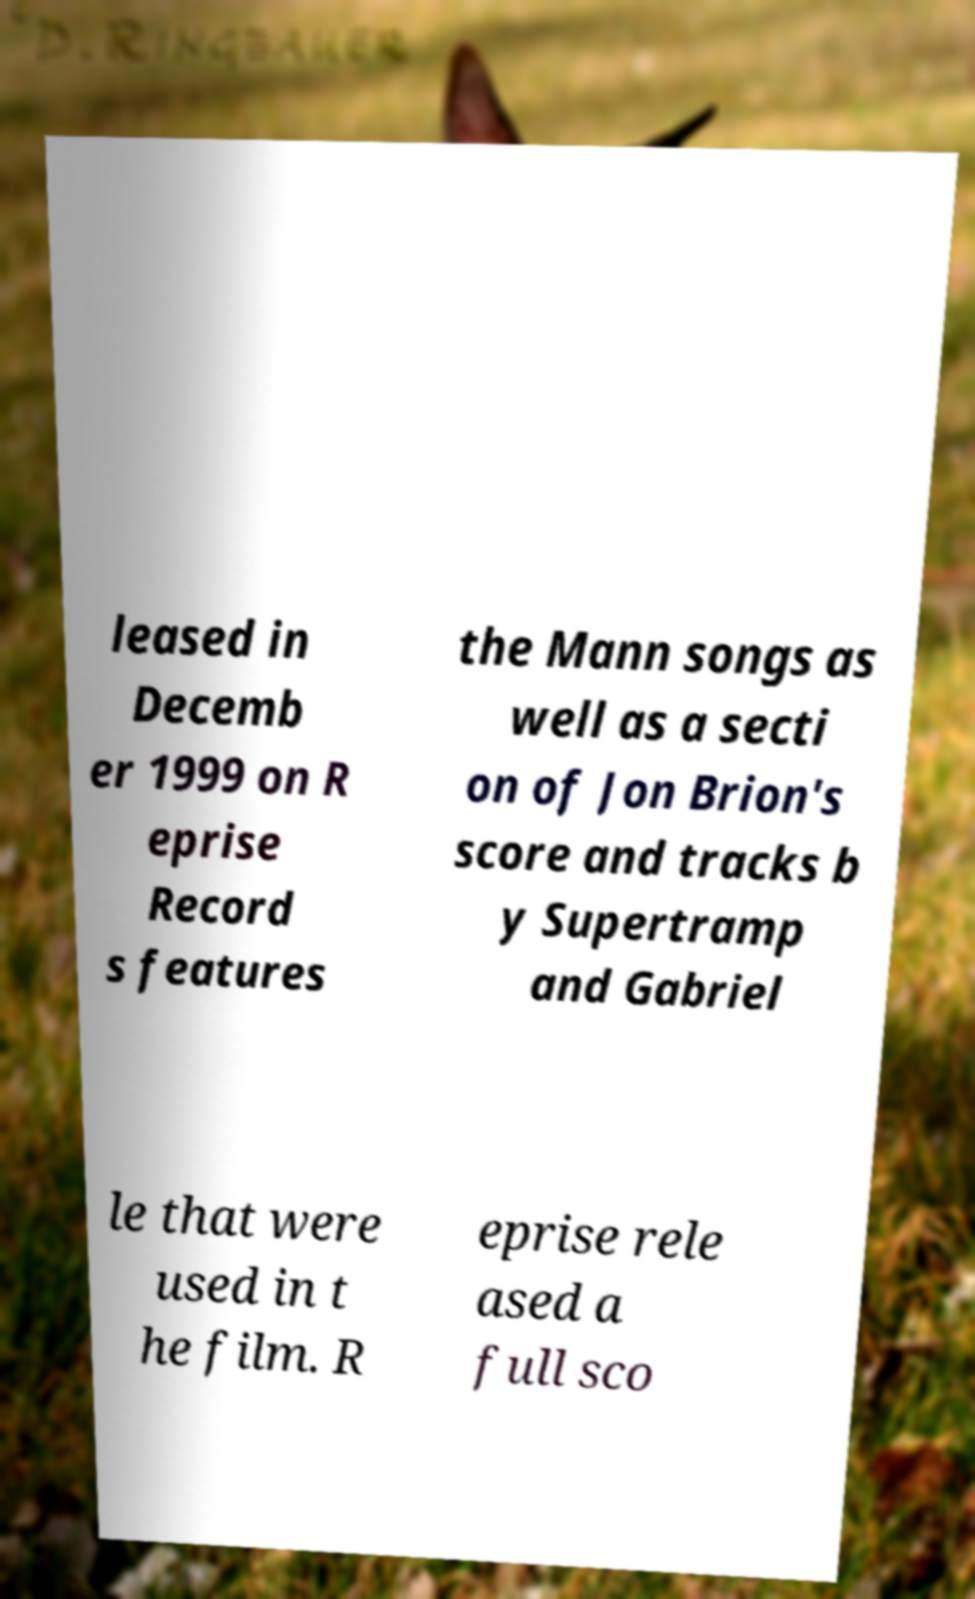For documentation purposes, I need the text within this image transcribed. Could you provide that? leased in Decemb er 1999 on R eprise Record s features the Mann songs as well as a secti on of Jon Brion's score and tracks b y Supertramp and Gabriel le that were used in t he film. R eprise rele ased a full sco 